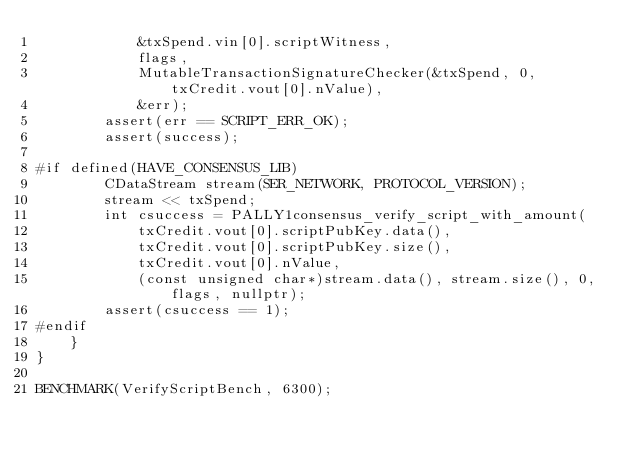Convert code to text. <code><loc_0><loc_0><loc_500><loc_500><_C++_>            &txSpend.vin[0].scriptWitness,
            flags,
            MutableTransactionSignatureChecker(&txSpend, 0, txCredit.vout[0].nValue),
            &err);
        assert(err == SCRIPT_ERR_OK);
        assert(success);

#if defined(HAVE_CONSENSUS_LIB)
        CDataStream stream(SER_NETWORK, PROTOCOL_VERSION);
        stream << txSpend;
        int csuccess = PALLY1consensus_verify_script_with_amount(
            txCredit.vout[0].scriptPubKey.data(),
            txCredit.vout[0].scriptPubKey.size(),
            txCredit.vout[0].nValue,
            (const unsigned char*)stream.data(), stream.size(), 0, flags, nullptr);
        assert(csuccess == 1);
#endif
    }
}

BENCHMARK(VerifyScriptBench, 6300);
</code> 